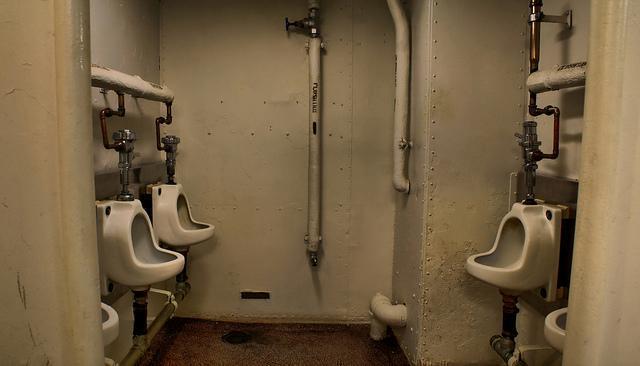What does the urinals use to wash away human waste?
Pick the right solution, then justify: 'Answer: answer
Rationale: rationale.'
Options: Waster, glue, air, magnets. Answer: waster.
Rationale: That is use to wash down human waste. 